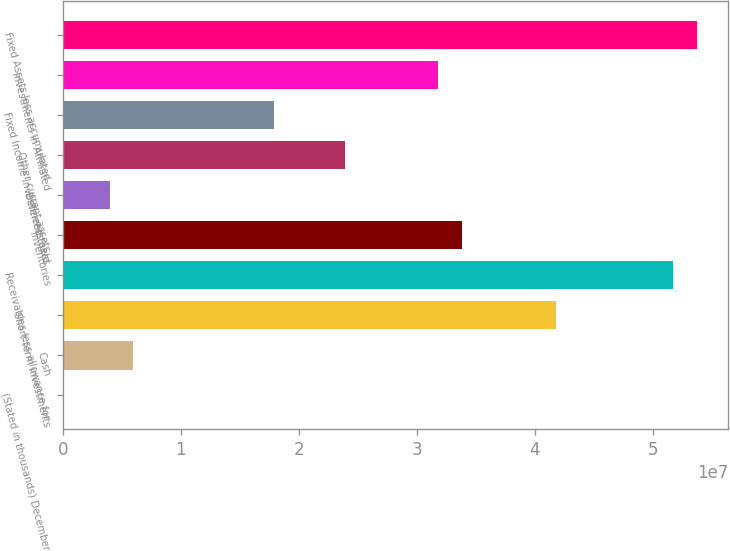Convert chart. <chart><loc_0><loc_0><loc_500><loc_500><bar_chart><fcel>(Stated in thousands) December<fcel>Cash<fcel>Short-term investments<fcel>Receivables less allowance for<fcel>Inventories<fcel>Deferred taxes<fcel>Other current assets<fcel>Fixed Income Investments held<fcel>Investments in Affiliated<fcel>Fixed Assets less accumulated<nl><fcel>2008<fcel>5.96866e+06<fcel>4.17686e+07<fcel>5.1713e+07<fcel>3.3813e+07<fcel>3.97977e+06<fcel>2.38686e+07<fcel>1.7902e+07<fcel>3.18241e+07<fcel>5.37019e+07<nl></chart> 